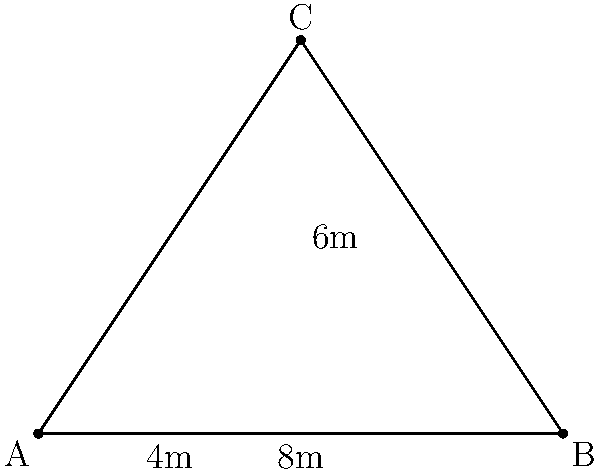In a triangular server room, three network devices are placed at the corners of an isosceles right triangle. The base of the triangle is 8 meters long, and a cable needs to run from the midpoint of the base to the opposite corner. Calculate the length of this cable to the nearest tenth of a meter. Let's approach this step-by-step:

1) The room forms an isosceles right triangle. This means two sides are equal, and one angle is 90°.

2) We're given that the base (AB) is 8 meters long.

3) The cable runs from the midpoint of AB to point C. Let's call this midpoint M.

4) AM = MB = 4 meters (half of 8 meters)

5) In a right-angled triangle, we can use the Pythagorean theorem: $a^2 + b^2 = c^2$

6) We need to find MC. We know AM (4m) and AC.

7) To find AC, we can use the properties of an isosceles right triangle:
   - The two equal sides form the right angle
   - Each equal side is $\frac{\text{base}}{\sqrt{2}}$

8) So, AC = $\frac{8}{\sqrt{2}} = 4\sqrt{2}$ meters

9) Now we can use Pythagorean theorem for triangle AMC:

   $AM^2 + MC^2 = AC^2$
   $4^2 + MC^2 = (4\sqrt{2})^2$
   $16 + MC^2 = 32$
   $MC^2 = 16$
   $MC = 4$ meters

10) Therefore, the length of the cable (MC) is 4 meters.
Answer: 4.0 m 